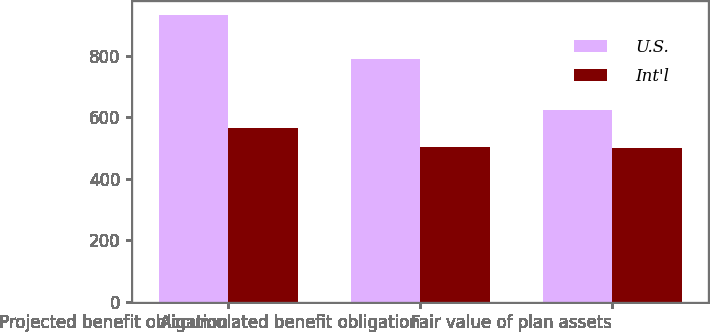Convert chart. <chart><loc_0><loc_0><loc_500><loc_500><stacked_bar_chart><ecel><fcel>Projected benefit obligation<fcel>Accumulated benefit obligation<fcel>Fair value of plan assets<nl><fcel>U.S.<fcel>933<fcel>791<fcel>625<nl><fcel>Int'l<fcel>565<fcel>505<fcel>500<nl></chart> 